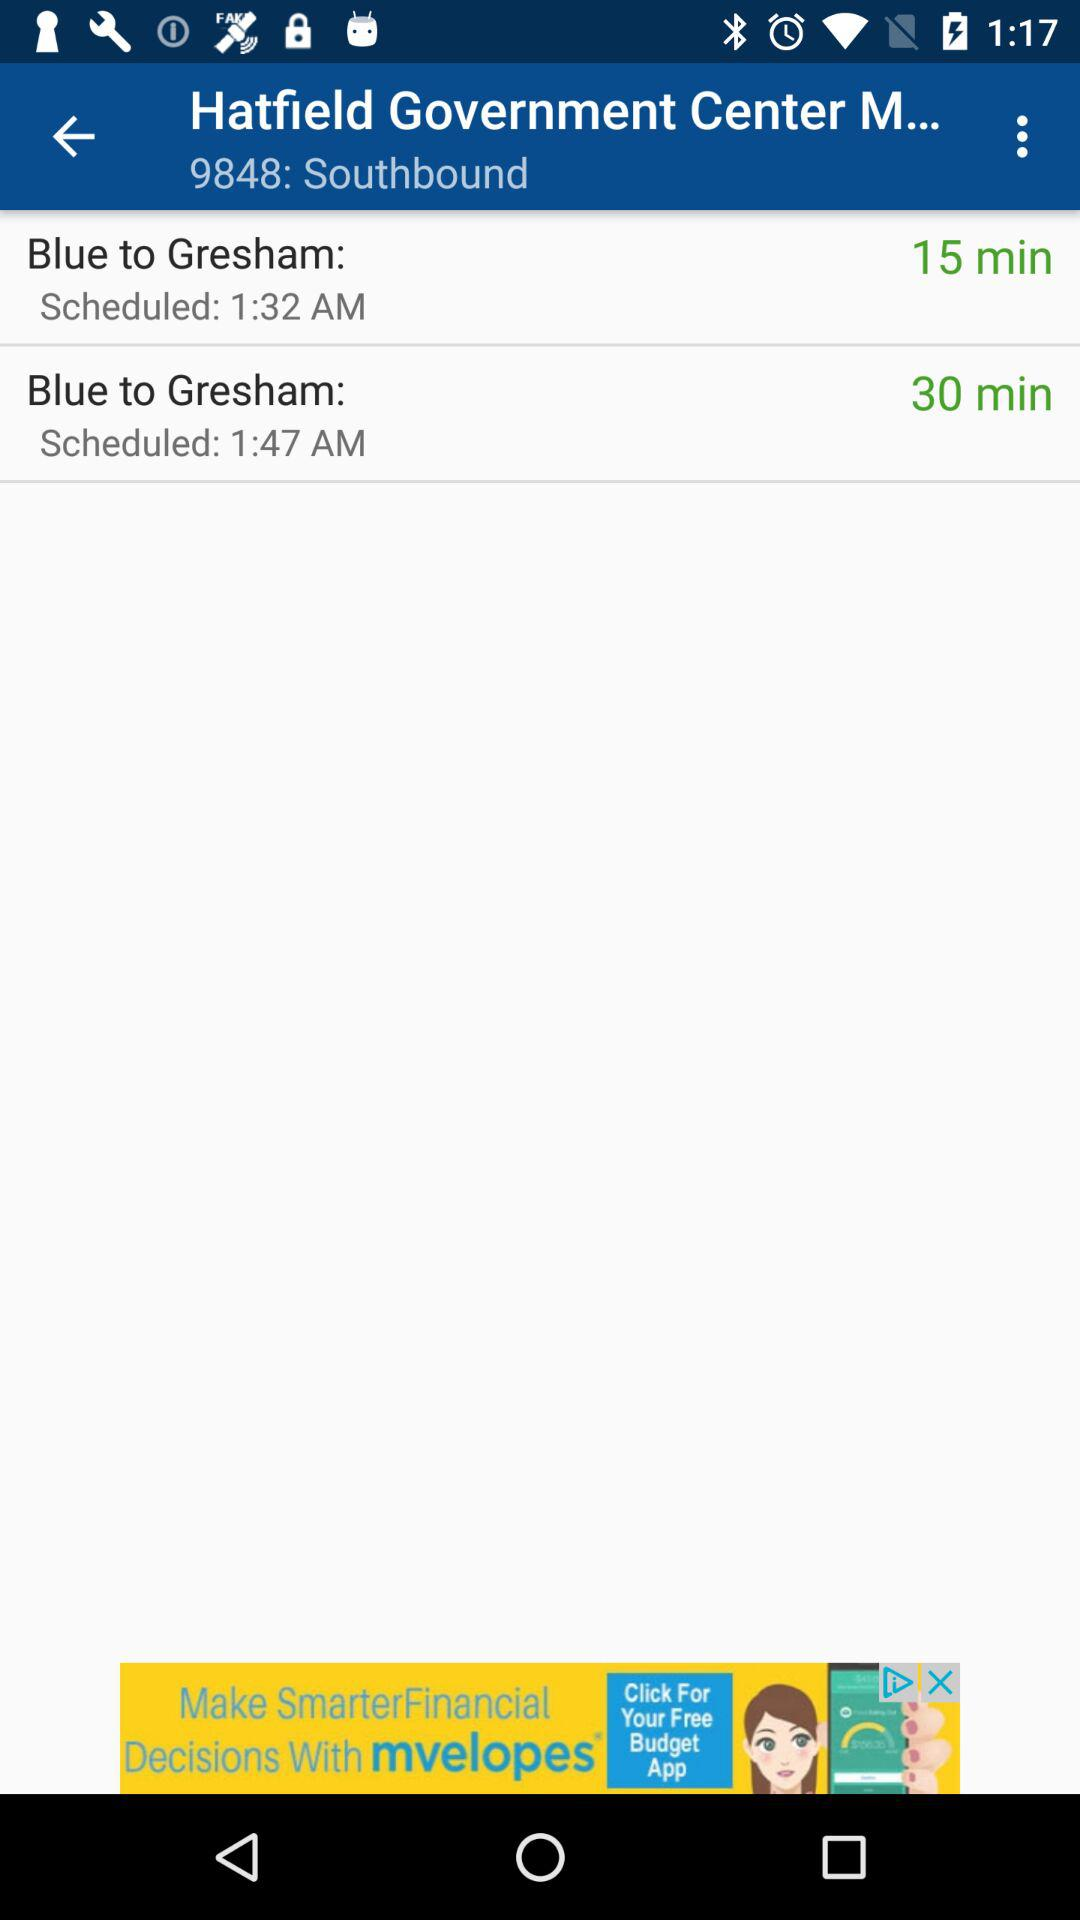What is the duration of Blue to Gresham at 1:32 am? The duration is "15 minutes". 